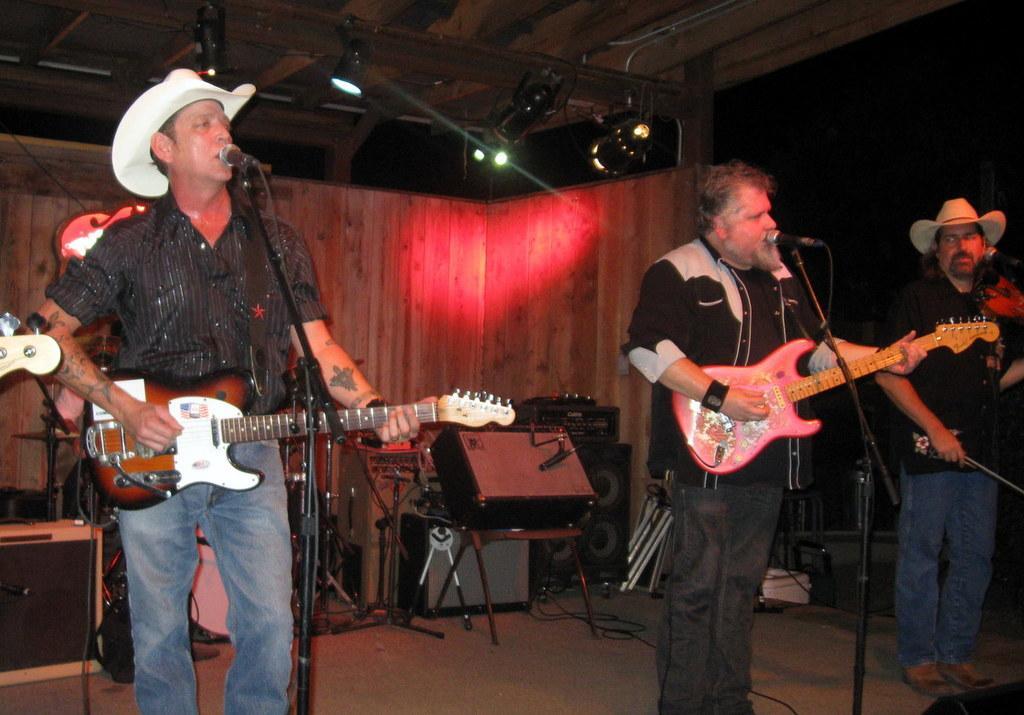Could you give a brief overview of what you see in this image? In this image there are few musicians playing musical instruments. In front of them there are mics. In the top there are lights. In the background there are few other musical instruments. 